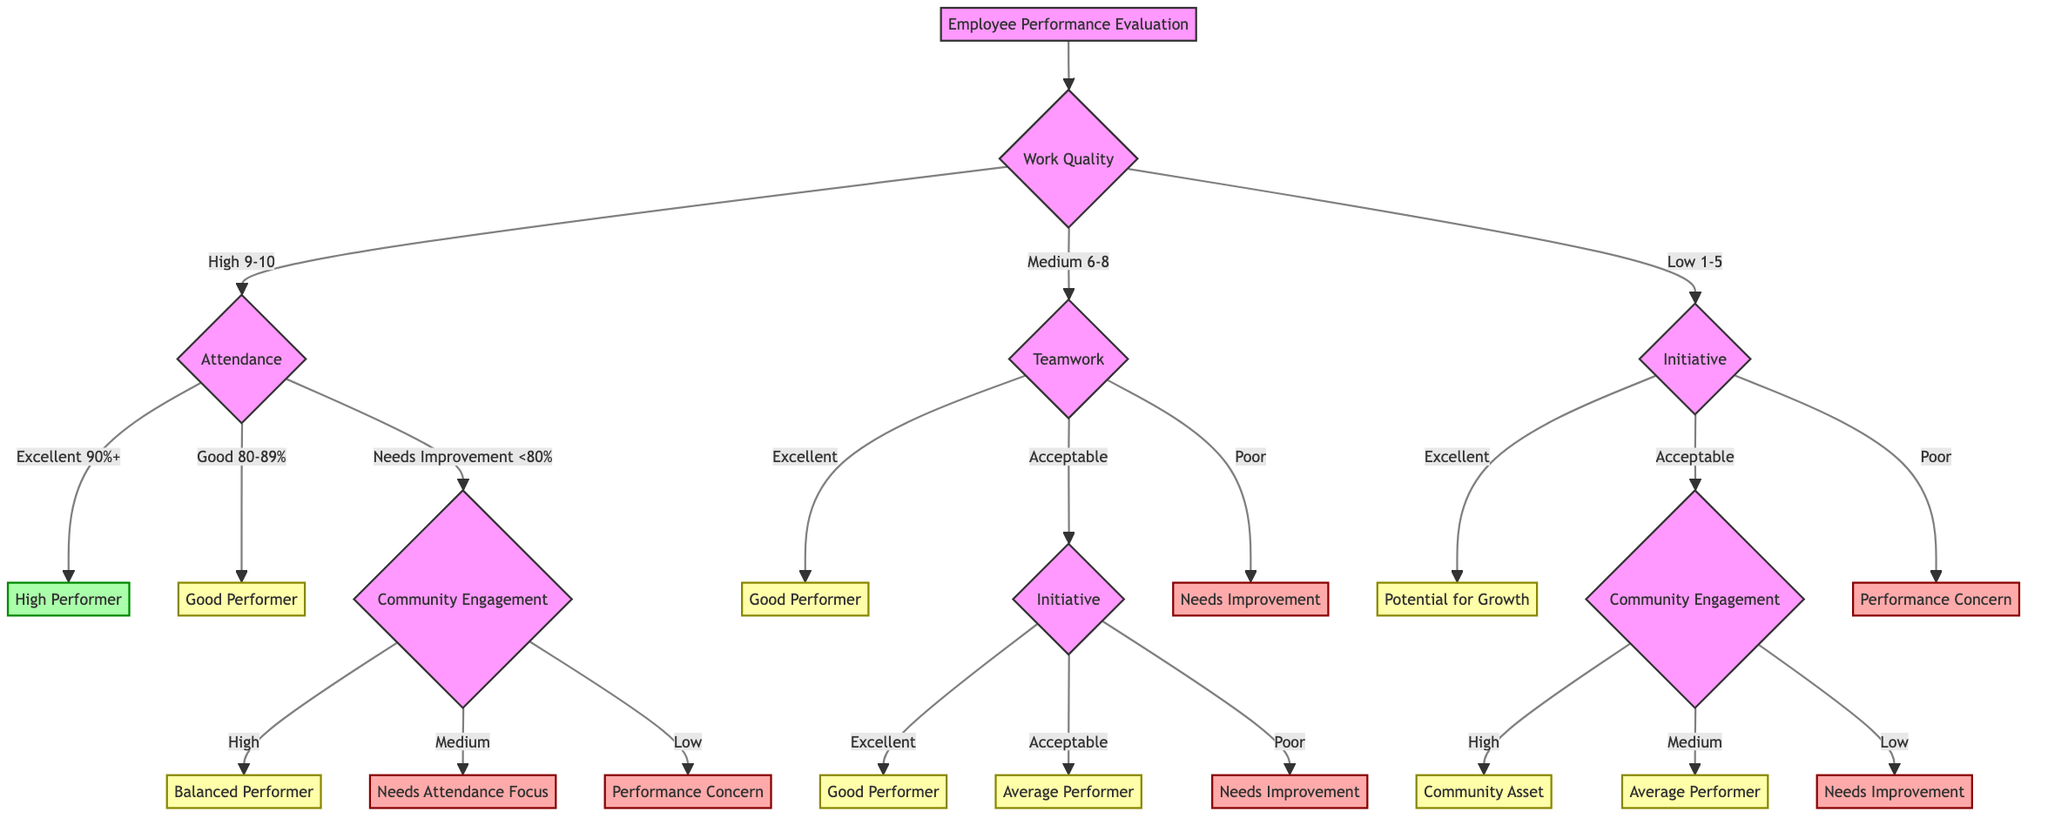What is the first criterion in the evaluation? The first criterion in the diagram is "Work Quality," which is the starting point for the decision tree.
Answer: Work Quality How many thresholds are defined for attendance? The attendance criterion has three thresholds: excellent, good, and needs improvement.
Answer: Three What does a high work quality indicate for attendance? A high work quality (9-10) leads to evaluating attendance. If attendance is excellent (90%+), the employee is classified as a high performer.
Answer: High Performer What performance label is assigned to someone with poor teamwork? If teamwork is classified as poor, the performance label assigned is "Needs Improvement."
Answer: Needs Improvement If an employee has low community engagement after having a good attendance, what is their performance category? If community engagement is low after needing improvement in attendance (<80%), the performance category is "Performance Concern."
Answer: Performance Concern What classification do you get with excellent teamwork and an acceptable initiative? With excellent teamwork, the decision will evaluate the initiative next; if initiative is acceptable, the classification is "Average Performer."
Answer: Average Performer What is the next evaluation point after a low work quality score? A low work quality score (1-5) leads to the evaluation of initiative as the next criterion to assess.
Answer: Initiative What does a medium community engagement with acceptable initiative yield as a performance label? A medium community engagement that follows an acceptable initiative results in classification as an "Average Performer."
Answer: Average Performer How many end nodes are there in total? The total number of end nodes in the decision tree is six: High Performer, Good Performer, Balanced Performer, Community Asset, Needs Improvement, and Performance Concern.
Answer: Six 